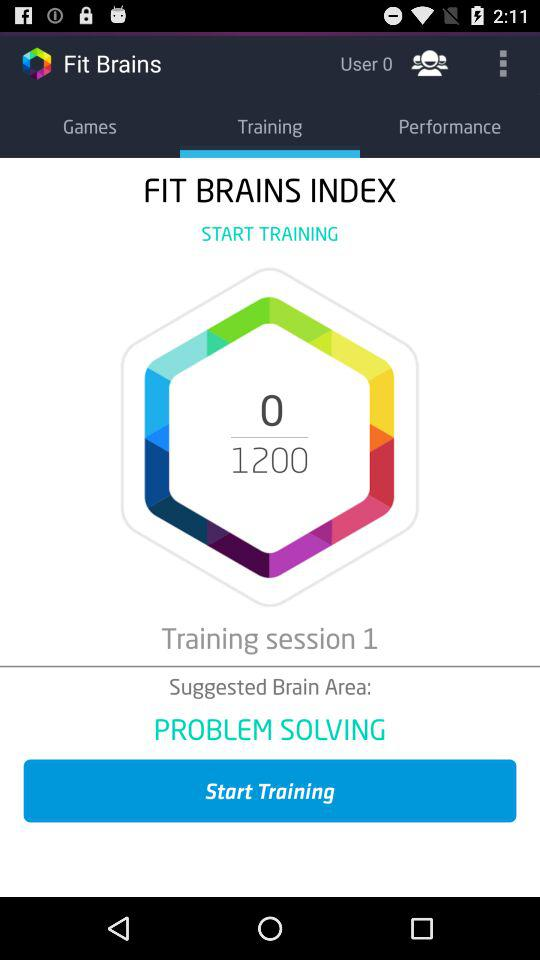How many more points are needed to reach the next training session?
Answer the question using a single word or phrase. 1200 